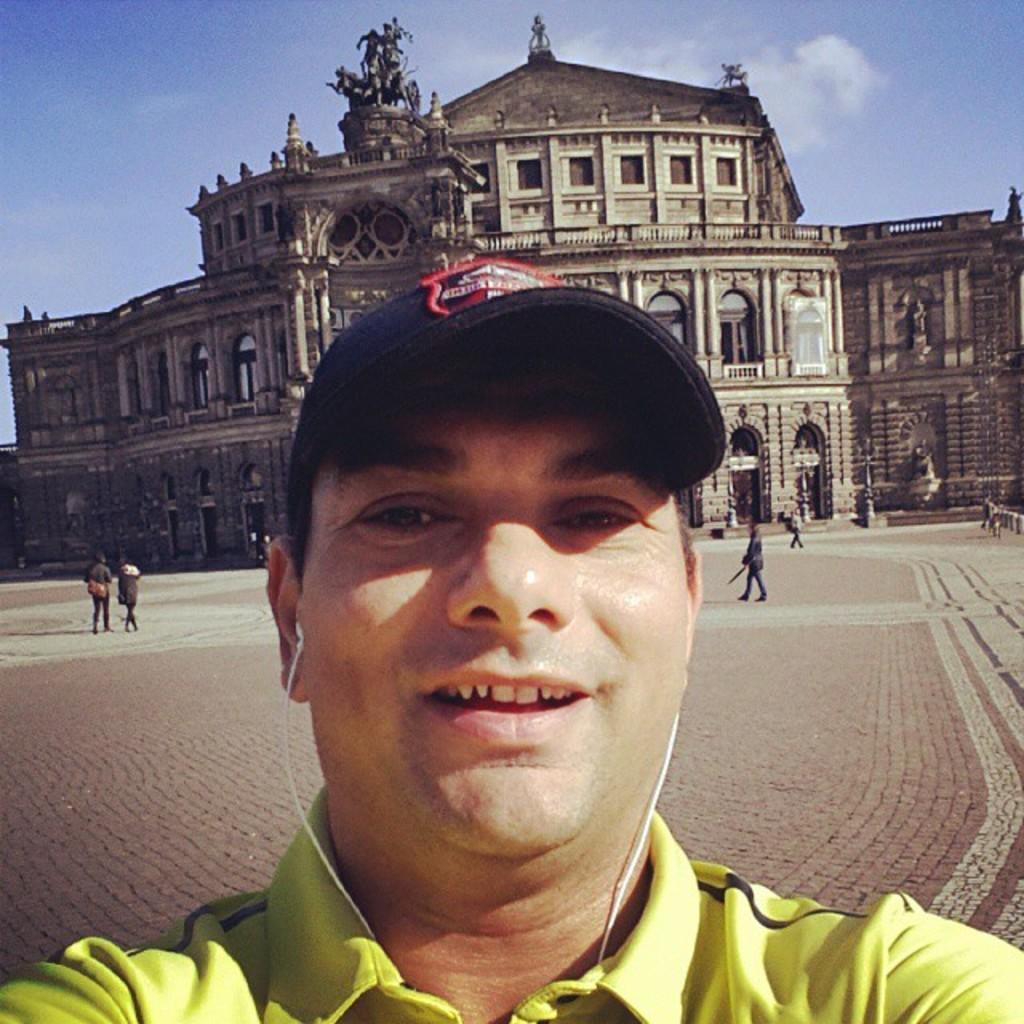In one or two sentences, can you explain what this image depicts? In the center of the image, we can see a person wearing a cap and earphones. In the background, there is a fort and we can see some people on the ground. At the top, there are clouds in the sky. 